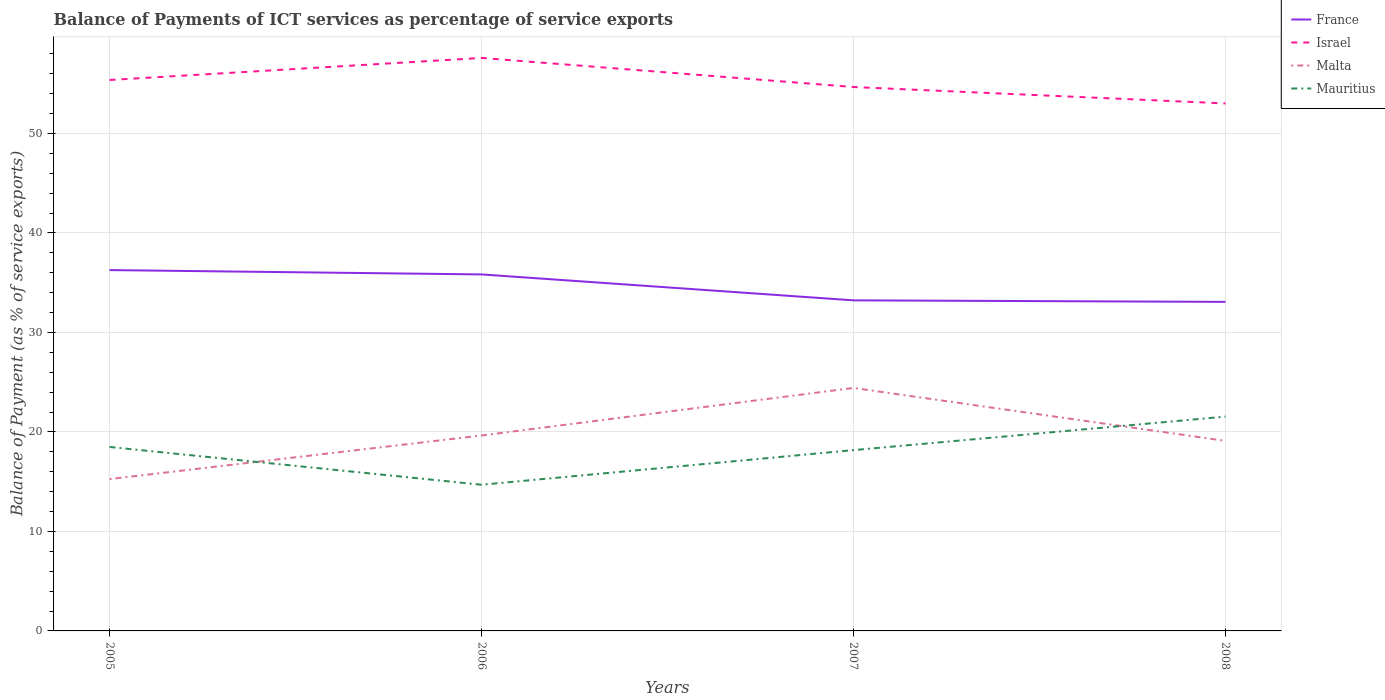Is the number of lines equal to the number of legend labels?
Provide a succinct answer. Yes. Across all years, what is the maximum balance of payments of ICT services in France?
Your answer should be very brief. 33.07. What is the total balance of payments of ICT services in Malta in the graph?
Give a very brief answer. 5.32. What is the difference between the highest and the second highest balance of payments of ICT services in Israel?
Your answer should be compact. 4.57. Are the values on the major ticks of Y-axis written in scientific E-notation?
Keep it short and to the point. No. Does the graph contain any zero values?
Your response must be concise. No. Where does the legend appear in the graph?
Offer a terse response. Top right. What is the title of the graph?
Provide a short and direct response. Balance of Payments of ICT services as percentage of service exports. Does "Lower middle income" appear as one of the legend labels in the graph?
Provide a succinct answer. No. What is the label or title of the Y-axis?
Your response must be concise. Balance of Payment (as % of service exports). What is the Balance of Payment (as % of service exports) of France in 2005?
Provide a succinct answer. 36.27. What is the Balance of Payment (as % of service exports) of Israel in 2005?
Make the answer very short. 55.37. What is the Balance of Payment (as % of service exports) of Malta in 2005?
Make the answer very short. 15.26. What is the Balance of Payment (as % of service exports) of Mauritius in 2005?
Your answer should be very brief. 18.49. What is the Balance of Payment (as % of service exports) of France in 2006?
Offer a very short reply. 35.83. What is the Balance of Payment (as % of service exports) of Israel in 2006?
Make the answer very short. 57.59. What is the Balance of Payment (as % of service exports) of Malta in 2006?
Keep it short and to the point. 19.64. What is the Balance of Payment (as % of service exports) in Mauritius in 2006?
Offer a very short reply. 14.69. What is the Balance of Payment (as % of service exports) of France in 2007?
Offer a terse response. 33.23. What is the Balance of Payment (as % of service exports) in Israel in 2007?
Your answer should be very brief. 54.67. What is the Balance of Payment (as % of service exports) of Malta in 2007?
Make the answer very short. 24.42. What is the Balance of Payment (as % of service exports) in Mauritius in 2007?
Your answer should be compact. 18.17. What is the Balance of Payment (as % of service exports) in France in 2008?
Provide a short and direct response. 33.07. What is the Balance of Payment (as % of service exports) in Israel in 2008?
Your answer should be compact. 53.02. What is the Balance of Payment (as % of service exports) in Malta in 2008?
Provide a short and direct response. 19.1. What is the Balance of Payment (as % of service exports) of Mauritius in 2008?
Your response must be concise. 21.54. Across all years, what is the maximum Balance of Payment (as % of service exports) in France?
Your response must be concise. 36.27. Across all years, what is the maximum Balance of Payment (as % of service exports) in Israel?
Keep it short and to the point. 57.59. Across all years, what is the maximum Balance of Payment (as % of service exports) in Malta?
Ensure brevity in your answer.  24.42. Across all years, what is the maximum Balance of Payment (as % of service exports) in Mauritius?
Provide a short and direct response. 21.54. Across all years, what is the minimum Balance of Payment (as % of service exports) of France?
Ensure brevity in your answer.  33.07. Across all years, what is the minimum Balance of Payment (as % of service exports) in Israel?
Ensure brevity in your answer.  53.02. Across all years, what is the minimum Balance of Payment (as % of service exports) in Malta?
Offer a terse response. 15.26. Across all years, what is the minimum Balance of Payment (as % of service exports) of Mauritius?
Give a very brief answer. 14.69. What is the total Balance of Payment (as % of service exports) of France in the graph?
Offer a terse response. 138.4. What is the total Balance of Payment (as % of service exports) in Israel in the graph?
Your answer should be very brief. 220.65. What is the total Balance of Payment (as % of service exports) of Malta in the graph?
Keep it short and to the point. 78.43. What is the total Balance of Payment (as % of service exports) of Mauritius in the graph?
Your response must be concise. 72.89. What is the difference between the Balance of Payment (as % of service exports) of France in 2005 and that in 2006?
Your answer should be very brief. 0.44. What is the difference between the Balance of Payment (as % of service exports) of Israel in 2005 and that in 2006?
Provide a short and direct response. -2.22. What is the difference between the Balance of Payment (as % of service exports) of Malta in 2005 and that in 2006?
Give a very brief answer. -4.39. What is the difference between the Balance of Payment (as % of service exports) of Mauritius in 2005 and that in 2006?
Make the answer very short. 3.8. What is the difference between the Balance of Payment (as % of service exports) of France in 2005 and that in 2007?
Your answer should be compact. 3.04. What is the difference between the Balance of Payment (as % of service exports) of Israel in 2005 and that in 2007?
Make the answer very short. 0.71. What is the difference between the Balance of Payment (as % of service exports) of Malta in 2005 and that in 2007?
Keep it short and to the point. -9.16. What is the difference between the Balance of Payment (as % of service exports) of Mauritius in 2005 and that in 2007?
Your answer should be very brief. 0.32. What is the difference between the Balance of Payment (as % of service exports) in France in 2005 and that in 2008?
Keep it short and to the point. 3.19. What is the difference between the Balance of Payment (as % of service exports) in Israel in 2005 and that in 2008?
Offer a very short reply. 2.36. What is the difference between the Balance of Payment (as % of service exports) of Malta in 2005 and that in 2008?
Give a very brief answer. -3.84. What is the difference between the Balance of Payment (as % of service exports) in Mauritius in 2005 and that in 2008?
Offer a very short reply. -3.05. What is the difference between the Balance of Payment (as % of service exports) of France in 2006 and that in 2007?
Provide a short and direct response. 2.61. What is the difference between the Balance of Payment (as % of service exports) in Israel in 2006 and that in 2007?
Your answer should be compact. 2.93. What is the difference between the Balance of Payment (as % of service exports) in Malta in 2006 and that in 2007?
Provide a short and direct response. -4.78. What is the difference between the Balance of Payment (as % of service exports) in Mauritius in 2006 and that in 2007?
Your response must be concise. -3.48. What is the difference between the Balance of Payment (as % of service exports) of France in 2006 and that in 2008?
Provide a succinct answer. 2.76. What is the difference between the Balance of Payment (as % of service exports) of Israel in 2006 and that in 2008?
Give a very brief answer. 4.57. What is the difference between the Balance of Payment (as % of service exports) of Malta in 2006 and that in 2008?
Ensure brevity in your answer.  0.54. What is the difference between the Balance of Payment (as % of service exports) of Mauritius in 2006 and that in 2008?
Ensure brevity in your answer.  -6.85. What is the difference between the Balance of Payment (as % of service exports) in France in 2007 and that in 2008?
Your answer should be very brief. 0.15. What is the difference between the Balance of Payment (as % of service exports) in Israel in 2007 and that in 2008?
Offer a terse response. 1.65. What is the difference between the Balance of Payment (as % of service exports) in Malta in 2007 and that in 2008?
Your response must be concise. 5.32. What is the difference between the Balance of Payment (as % of service exports) in Mauritius in 2007 and that in 2008?
Offer a very short reply. -3.37. What is the difference between the Balance of Payment (as % of service exports) of France in 2005 and the Balance of Payment (as % of service exports) of Israel in 2006?
Your answer should be very brief. -21.33. What is the difference between the Balance of Payment (as % of service exports) in France in 2005 and the Balance of Payment (as % of service exports) in Malta in 2006?
Provide a succinct answer. 16.62. What is the difference between the Balance of Payment (as % of service exports) of France in 2005 and the Balance of Payment (as % of service exports) of Mauritius in 2006?
Offer a terse response. 21.58. What is the difference between the Balance of Payment (as % of service exports) in Israel in 2005 and the Balance of Payment (as % of service exports) in Malta in 2006?
Keep it short and to the point. 35.73. What is the difference between the Balance of Payment (as % of service exports) of Israel in 2005 and the Balance of Payment (as % of service exports) of Mauritius in 2006?
Keep it short and to the point. 40.68. What is the difference between the Balance of Payment (as % of service exports) in Malta in 2005 and the Balance of Payment (as % of service exports) in Mauritius in 2006?
Provide a succinct answer. 0.57. What is the difference between the Balance of Payment (as % of service exports) of France in 2005 and the Balance of Payment (as % of service exports) of Israel in 2007?
Provide a short and direct response. -18.4. What is the difference between the Balance of Payment (as % of service exports) in France in 2005 and the Balance of Payment (as % of service exports) in Malta in 2007?
Offer a very short reply. 11.85. What is the difference between the Balance of Payment (as % of service exports) of France in 2005 and the Balance of Payment (as % of service exports) of Mauritius in 2007?
Ensure brevity in your answer.  18.09. What is the difference between the Balance of Payment (as % of service exports) of Israel in 2005 and the Balance of Payment (as % of service exports) of Malta in 2007?
Your answer should be compact. 30.95. What is the difference between the Balance of Payment (as % of service exports) of Israel in 2005 and the Balance of Payment (as % of service exports) of Mauritius in 2007?
Ensure brevity in your answer.  37.2. What is the difference between the Balance of Payment (as % of service exports) in Malta in 2005 and the Balance of Payment (as % of service exports) in Mauritius in 2007?
Ensure brevity in your answer.  -2.92. What is the difference between the Balance of Payment (as % of service exports) of France in 2005 and the Balance of Payment (as % of service exports) of Israel in 2008?
Offer a terse response. -16.75. What is the difference between the Balance of Payment (as % of service exports) in France in 2005 and the Balance of Payment (as % of service exports) in Malta in 2008?
Offer a very short reply. 17.17. What is the difference between the Balance of Payment (as % of service exports) in France in 2005 and the Balance of Payment (as % of service exports) in Mauritius in 2008?
Your response must be concise. 14.73. What is the difference between the Balance of Payment (as % of service exports) of Israel in 2005 and the Balance of Payment (as % of service exports) of Malta in 2008?
Keep it short and to the point. 36.27. What is the difference between the Balance of Payment (as % of service exports) in Israel in 2005 and the Balance of Payment (as % of service exports) in Mauritius in 2008?
Keep it short and to the point. 33.83. What is the difference between the Balance of Payment (as % of service exports) of Malta in 2005 and the Balance of Payment (as % of service exports) of Mauritius in 2008?
Your response must be concise. -6.28. What is the difference between the Balance of Payment (as % of service exports) of France in 2006 and the Balance of Payment (as % of service exports) of Israel in 2007?
Offer a very short reply. -18.83. What is the difference between the Balance of Payment (as % of service exports) of France in 2006 and the Balance of Payment (as % of service exports) of Malta in 2007?
Keep it short and to the point. 11.41. What is the difference between the Balance of Payment (as % of service exports) in France in 2006 and the Balance of Payment (as % of service exports) in Mauritius in 2007?
Your response must be concise. 17.66. What is the difference between the Balance of Payment (as % of service exports) of Israel in 2006 and the Balance of Payment (as % of service exports) of Malta in 2007?
Your answer should be compact. 33.17. What is the difference between the Balance of Payment (as % of service exports) in Israel in 2006 and the Balance of Payment (as % of service exports) in Mauritius in 2007?
Provide a succinct answer. 39.42. What is the difference between the Balance of Payment (as % of service exports) of Malta in 2006 and the Balance of Payment (as % of service exports) of Mauritius in 2007?
Your response must be concise. 1.47. What is the difference between the Balance of Payment (as % of service exports) in France in 2006 and the Balance of Payment (as % of service exports) in Israel in 2008?
Offer a terse response. -17.19. What is the difference between the Balance of Payment (as % of service exports) in France in 2006 and the Balance of Payment (as % of service exports) in Malta in 2008?
Give a very brief answer. 16.73. What is the difference between the Balance of Payment (as % of service exports) in France in 2006 and the Balance of Payment (as % of service exports) in Mauritius in 2008?
Your answer should be compact. 14.29. What is the difference between the Balance of Payment (as % of service exports) of Israel in 2006 and the Balance of Payment (as % of service exports) of Malta in 2008?
Keep it short and to the point. 38.49. What is the difference between the Balance of Payment (as % of service exports) of Israel in 2006 and the Balance of Payment (as % of service exports) of Mauritius in 2008?
Offer a terse response. 36.05. What is the difference between the Balance of Payment (as % of service exports) of Malta in 2006 and the Balance of Payment (as % of service exports) of Mauritius in 2008?
Your answer should be very brief. -1.9. What is the difference between the Balance of Payment (as % of service exports) in France in 2007 and the Balance of Payment (as % of service exports) in Israel in 2008?
Keep it short and to the point. -19.79. What is the difference between the Balance of Payment (as % of service exports) of France in 2007 and the Balance of Payment (as % of service exports) of Malta in 2008?
Your response must be concise. 14.12. What is the difference between the Balance of Payment (as % of service exports) of France in 2007 and the Balance of Payment (as % of service exports) of Mauritius in 2008?
Provide a short and direct response. 11.69. What is the difference between the Balance of Payment (as % of service exports) in Israel in 2007 and the Balance of Payment (as % of service exports) in Malta in 2008?
Keep it short and to the point. 35.57. What is the difference between the Balance of Payment (as % of service exports) in Israel in 2007 and the Balance of Payment (as % of service exports) in Mauritius in 2008?
Make the answer very short. 33.13. What is the difference between the Balance of Payment (as % of service exports) of Malta in 2007 and the Balance of Payment (as % of service exports) of Mauritius in 2008?
Your response must be concise. 2.88. What is the average Balance of Payment (as % of service exports) in France per year?
Provide a short and direct response. 34.6. What is the average Balance of Payment (as % of service exports) in Israel per year?
Offer a very short reply. 55.16. What is the average Balance of Payment (as % of service exports) in Malta per year?
Keep it short and to the point. 19.61. What is the average Balance of Payment (as % of service exports) in Mauritius per year?
Provide a short and direct response. 18.22. In the year 2005, what is the difference between the Balance of Payment (as % of service exports) in France and Balance of Payment (as % of service exports) in Israel?
Offer a very short reply. -19.11. In the year 2005, what is the difference between the Balance of Payment (as % of service exports) in France and Balance of Payment (as % of service exports) in Malta?
Give a very brief answer. 21.01. In the year 2005, what is the difference between the Balance of Payment (as % of service exports) in France and Balance of Payment (as % of service exports) in Mauritius?
Make the answer very short. 17.78. In the year 2005, what is the difference between the Balance of Payment (as % of service exports) in Israel and Balance of Payment (as % of service exports) in Malta?
Your answer should be very brief. 40.12. In the year 2005, what is the difference between the Balance of Payment (as % of service exports) in Israel and Balance of Payment (as % of service exports) in Mauritius?
Ensure brevity in your answer.  36.88. In the year 2005, what is the difference between the Balance of Payment (as % of service exports) in Malta and Balance of Payment (as % of service exports) in Mauritius?
Offer a very short reply. -3.23. In the year 2006, what is the difference between the Balance of Payment (as % of service exports) in France and Balance of Payment (as % of service exports) in Israel?
Provide a short and direct response. -21.76. In the year 2006, what is the difference between the Balance of Payment (as % of service exports) in France and Balance of Payment (as % of service exports) in Malta?
Your answer should be very brief. 16.19. In the year 2006, what is the difference between the Balance of Payment (as % of service exports) in France and Balance of Payment (as % of service exports) in Mauritius?
Keep it short and to the point. 21.14. In the year 2006, what is the difference between the Balance of Payment (as % of service exports) in Israel and Balance of Payment (as % of service exports) in Malta?
Provide a succinct answer. 37.95. In the year 2006, what is the difference between the Balance of Payment (as % of service exports) of Israel and Balance of Payment (as % of service exports) of Mauritius?
Provide a short and direct response. 42.9. In the year 2006, what is the difference between the Balance of Payment (as % of service exports) of Malta and Balance of Payment (as % of service exports) of Mauritius?
Your response must be concise. 4.95. In the year 2007, what is the difference between the Balance of Payment (as % of service exports) in France and Balance of Payment (as % of service exports) in Israel?
Provide a short and direct response. -21.44. In the year 2007, what is the difference between the Balance of Payment (as % of service exports) of France and Balance of Payment (as % of service exports) of Malta?
Make the answer very short. 8.8. In the year 2007, what is the difference between the Balance of Payment (as % of service exports) in France and Balance of Payment (as % of service exports) in Mauritius?
Offer a terse response. 15.05. In the year 2007, what is the difference between the Balance of Payment (as % of service exports) of Israel and Balance of Payment (as % of service exports) of Malta?
Offer a terse response. 30.24. In the year 2007, what is the difference between the Balance of Payment (as % of service exports) of Israel and Balance of Payment (as % of service exports) of Mauritius?
Offer a very short reply. 36.49. In the year 2007, what is the difference between the Balance of Payment (as % of service exports) of Malta and Balance of Payment (as % of service exports) of Mauritius?
Keep it short and to the point. 6.25. In the year 2008, what is the difference between the Balance of Payment (as % of service exports) of France and Balance of Payment (as % of service exports) of Israel?
Make the answer very short. -19.94. In the year 2008, what is the difference between the Balance of Payment (as % of service exports) in France and Balance of Payment (as % of service exports) in Malta?
Provide a succinct answer. 13.97. In the year 2008, what is the difference between the Balance of Payment (as % of service exports) in France and Balance of Payment (as % of service exports) in Mauritius?
Provide a short and direct response. 11.53. In the year 2008, what is the difference between the Balance of Payment (as % of service exports) in Israel and Balance of Payment (as % of service exports) in Malta?
Provide a short and direct response. 33.92. In the year 2008, what is the difference between the Balance of Payment (as % of service exports) in Israel and Balance of Payment (as % of service exports) in Mauritius?
Offer a terse response. 31.48. In the year 2008, what is the difference between the Balance of Payment (as % of service exports) in Malta and Balance of Payment (as % of service exports) in Mauritius?
Keep it short and to the point. -2.44. What is the ratio of the Balance of Payment (as % of service exports) of France in 2005 to that in 2006?
Keep it short and to the point. 1.01. What is the ratio of the Balance of Payment (as % of service exports) of Israel in 2005 to that in 2006?
Provide a short and direct response. 0.96. What is the ratio of the Balance of Payment (as % of service exports) in Malta in 2005 to that in 2006?
Offer a very short reply. 0.78. What is the ratio of the Balance of Payment (as % of service exports) in Mauritius in 2005 to that in 2006?
Your answer should be very brief. 1.26. What is the ratio of the Balance of Payment (as % of service exports) of France in 2005 to that in 2007?
Your response must be concise. 1.09. What is the ratio of the Balance of Payment (as % of service exports) of Israel in 2005 to that in 2007?
Provide a short and direct response. 1.01. What is the ratio of the Balance of Payment (as % of service exports) of Malta in 2005 to that in 2007?
Offer a very short reply. 0.62. What is the ratio of the Balance of Payment (as % of service exports) in Mauritius in 2005 to that in 2007?
Make the answer very short. 1.02. What is the ratio of the Balance of Payment (as % of service exports) in France in 2005 to that in 2008?
Your answer should be very brief. 1.1. What is the ratio of the Balance of Payment (as % of service exports) of Israel in 2005 to that in 2008?
Offer a terse response. 1.04. What is the ratio of the Balance of Payment (as % of service exports) of Malta in 2005 to that in 2008?
Your answer should be compact. 0.8. What is the ratio of the Balance of Payment (as % of service exports) of Mauritius in 2005 to that in 2008?
Provide a succinct answer. 0.86. What is the ratio of the Balance of Payment (as % of service exports) of France in 2006 to that in 2007?
Give a very brief answer. 1.08. What is the ratio of the Balance of Payment (as % of service exports) of Israel in 2006 to that in 2007?
Your answer should be compact. 1.05. What is the ratio of the Balance of Payment (as % of service exports) in Malta in 2006 to that in 2007?
Your response must be concise. 0.8. What is the ratio of the Balance of Payment (as % of service exports) of Mauritius in 2006 to that in 2007?
Provide a short and direct response. 0.81. What is the ratio of the Balance of Payment (as % of service exports) of France in 2006 to that in 2008?
Provide a short and direct response. 1.08. What is the ratio of the Balance of Payment (as % of service exports) in Israel in 2006 to that in 2008?
Provide a succinct answer. 1.09. What is the ratio of the Balance of Payment (as % of service exports) in Malta in 2006 to that in 2008?
Your answer should be very brief. 1.03. What is the ratio of the Balance of Payment (as % of service exports) in Mauritius in 2006 to that in 2008?
Provide a succinct answer. 0.68. What is the ratio of the Balance of Payment (as % of service exports) in Israel in 2007 to that in 2008?
Offer a very short reply. 1.03. What is the ratio of the Balance of Payment (as % of service exports) of Malta in 2007 to that in 2008?
Your answer should be compact. 1.28. What is the ratio of the Balance of Payment (as % of service exports) of Mauritius in 2007 to that in 2008?
Provide a short and direct response. 0.84. What is the difference between the highest and the second highest Balance of Payment (as % of service exports) in France?
Offer a very short reply. 0.44. What is the difference between the highest and the second highest Balance of Payment (as % of service exports) of Israel?
Provide a succinct answer. 2.22. What is the difference between the highest and the second highest Balance of Payment (as % of service exports) in Malta?
Your answer should be compact. 4.78. What is the difference between the highest and the second highest Balance of Payment (as % of service exports) of Mauritius?
Give a very brief answer. 3.05. What is the difference between the highest and the lowest Balance of Payment (as % of service exports) of France?
Make the answer very short. 3.19. What is the difference between the highest and the lowest Balance of Payment (as % of service exports) of Israel?
Your answer should be very brief. 4.57. What is the difference between the highest and the lowest Balance of Payment (as % of service exports) in Malta?
Provide a short and direct response. 9.16. What is the difference between the highest and the lowest Balance of Payment (as % of service exports) in Mauritius?
Your answer should be very brief. 6.85. 